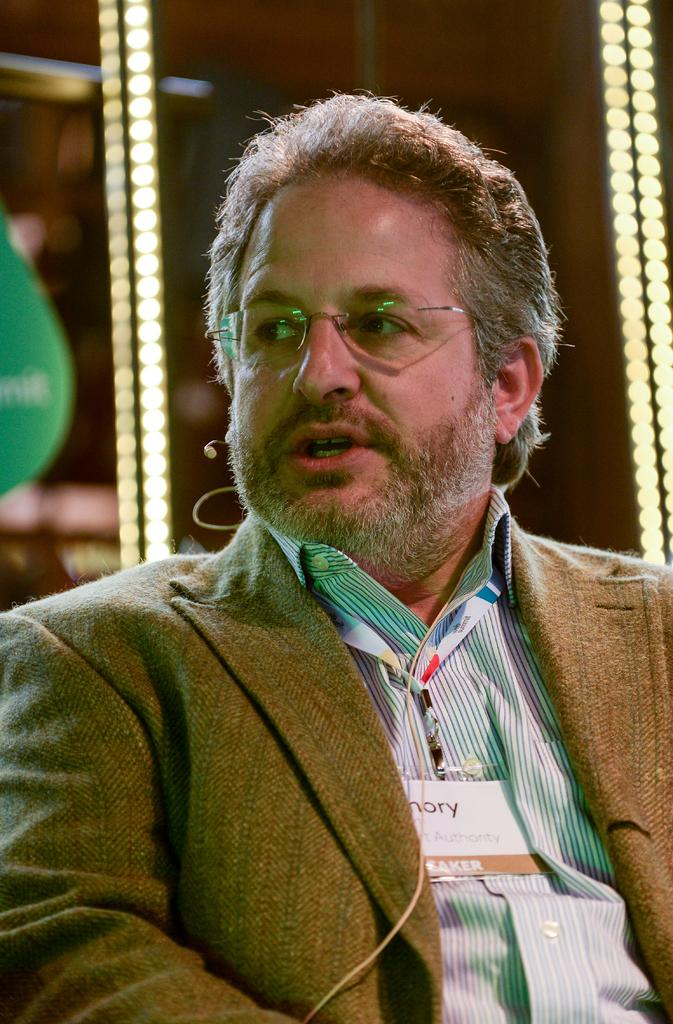What is the person in the image doing? There is a person sitting in the image. In which direction is the person looking? The person is looking to the left side of the image. What can be seen in the background or surroundings of the image? There are lights visible in the image. What object is present in the image that is typically associated with celebrations or parties? There is a balloon in the image. What type of trail can be seen behind the person in the image? There is no trail visible behind the person in the image. 